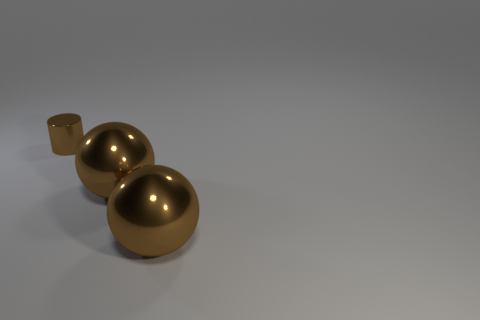Add 3 large metal cylinders. How many objects exist? 6 Subtract 1 cylinders. How many cylinders are left? 0 Add 3 big brown metal objects. How many big brown metal objects are left? 5 Add 2 large purple metal cubes. How many large purple metal cubes exist? 2 Subtract 0 blue balls. How many objects are left? 3 Subtract all balls. How many objects are left? 1 Subtract all gray cylinders. Subtract all cyan balls. How many cylinders are left? 1 Subtract all tiny things. Subtract all large shiny balls. How many objects are left? 0 